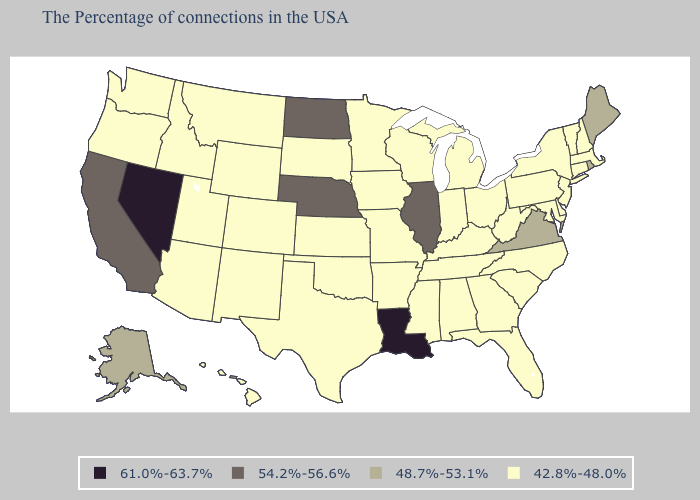Does Florida have the same value as Nevada?
Give a very brief answer. No. Which states have the lowest value in the USA?
Give a very brief answer. Massachusetts, New Hampshire, Vermont, Connecticut, New York, New Jersey, Delaware, Maryland, Pennsylvania, North Carolina, South Carolina, West Virginia, Ohio, Florida, Georgia, Michigan, Kentucky, Indiana, Alabama, Tennessee, Wisconsin, Mississippi, Missouri, Arkansas, Minnesota, Iowa, Kansas, Oklahoma, Texas, South Dakota, Wyoming, Colorado, New Mexico, Utah, Montana, Arizona, Idaho, Washington, Oregon, Hawaii. Among the states that border California , which have the highest value?
Give a very brief answer. Nevada. Among the states that border Iowa , which have the highest value?
Short answer required. Illinois, Nebraska. Does Indiana have a lower value than Maine?
Concise answer only. Yes. What is the value of Alabama?
Short answer required. 42.8%-48.0%. What is the value of Idaho?
Quick response, please. 42.8%-48.0%. What is the value of Vermont?
Concise answer only. 42.8%-48.0%. Does Illinois have the highest value in the MidWest?
Short answer required. Yes. Does Wisconsin have a lower value than Louisiana?
Concise answer only. Yes. What is the lowest value in the USA?
Answer briefly. 42.8%-48.0%. Does the first symbol in the legend represent the smallest category?
Short answer required. No. Does Missouri have a higher value than Iowa?
Be succinct. No. 